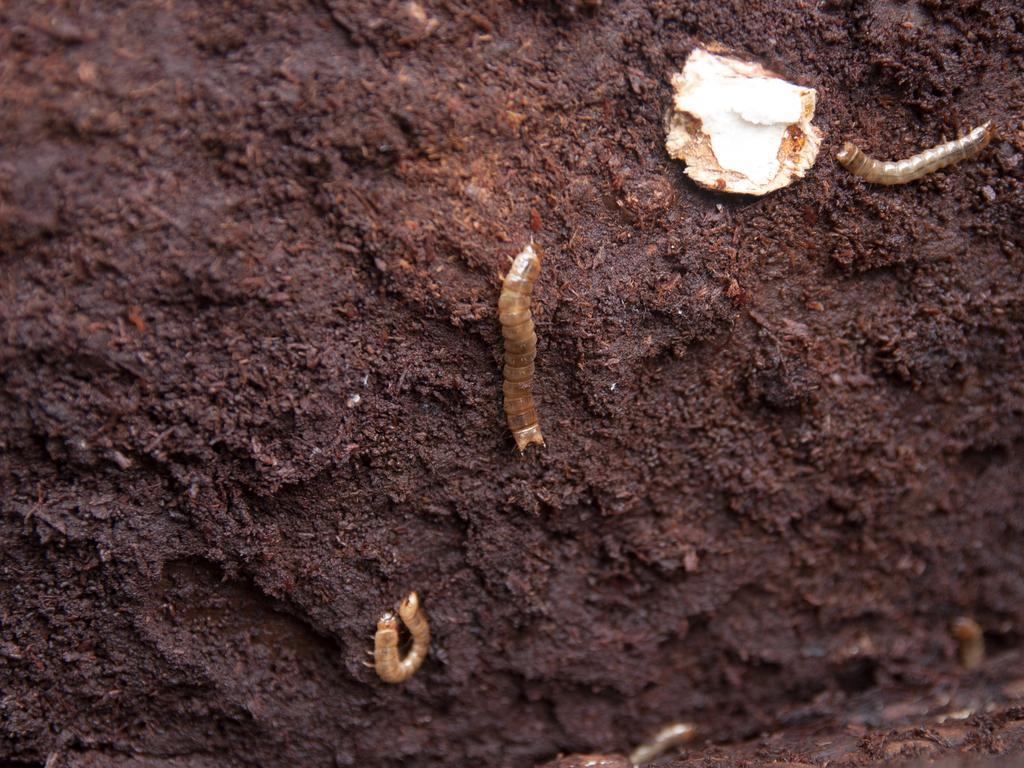What can be seen at the bottom of the image? The ground is visible at the bottom of the image. What type of creatures are present in the image? There are worms in the image. What is the primary color of the background in the image? The background of the image appears to be mud. What type of ball can be seen in the image? There is no ball present in the image; it features worms and a muddy background. How many boys are interacting with the worms in the image? There are no boys present in the image; it only features worms and a muddy background. 